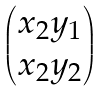Convert formula to latex. <formula><loc_0><loc_0><loc_500><loc_500>\begin{pmatrix} x _ { 2 } y _ { 1 } \\ x _ { 2 } y _ { 2 } \end{pmatrix}</formula> 